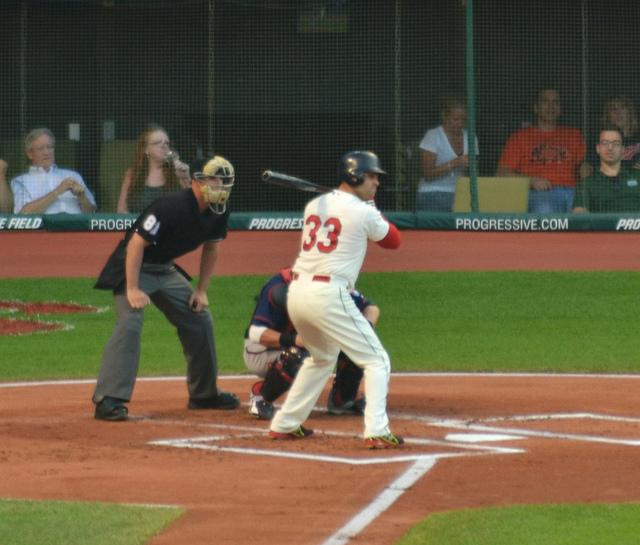What is he doing?
Concise answer only. Batting. What number is at bat?
Concise answer only. 33. What number is on the batters uniform?
Keep it brief. 33. What is his jersey number?
Keep it brief. 33. What is the man called behind the batter?
Quick response, please. Catcher. What number is on the players shirt?
Keep it brief. 33. Which base is this?
Quick response, please. Home. What is the batter's number?
Answer briefly. 33. What is the man carrying in his left hand?
Give a very brief answer. Bat. What is the current score of the game?
Quick response, please. Not sure. What is the logo on the shoes?
Concise answer only. Nike. What color is the base?
Answer briefly. White. Is the umpire touching the catcher?
Short answer required. No. Has the batter already swung the bat?
Quick response, please. No. 